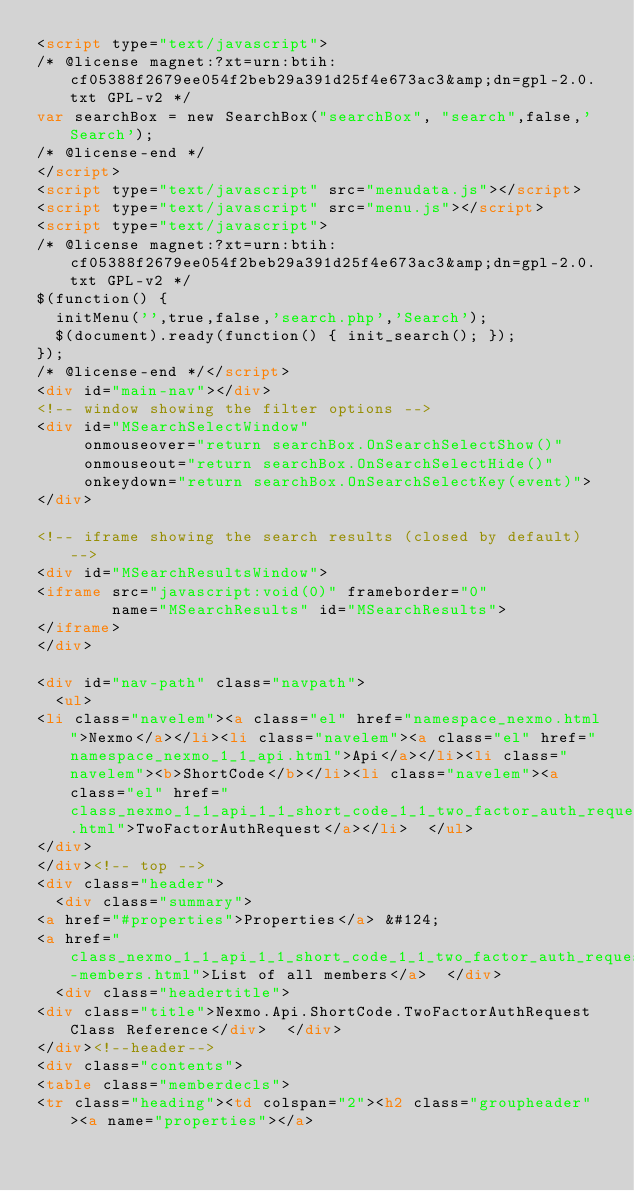Convert code to text. <code><loc_0><loc_0><loc_500><loc_500><_HTML_><script type="text/javascript">
/* @license magnet:?xt=urn:btih:cf05388f2679ee054f2beb29a391d25f4e673ac3&amp;dn=gpl-2.0.txt GPL-v2 */
var searchBox = new SearchBox("searchBox", "search",false,'Search');
/* @license-end */
</script>
<script type="text/javascript" src="menudata.js"></script>
<script type="text/javascript" src="menu.js"></script>
<script type="text/javascript">
/* @license magnet:?xt=urn:btih:cf05388f2679ee054f2beb29a391d25f4e673ac3&amp;dn=gpl-2.0.txt GPL-v2 */
$(function() {
  initMenu('',true,false,'search.php','Search');
  $(document).ready(function() { init_search(); });
});
/* @license-end */</script>
<div id="main-nav"></div>
<!-- window showing the filter options -->
<div id="MSearchSelectWindow"
     onmouseover="return searchBox.OnSearchSelectShow()"
     onmouseout="return searchBox.OnSearchSelectHide()"
     onkeydown="return searchBox.OnSearchSelectKey(event)">
</div>

<!-- iframe showing the search results (closed by default) -->
<div id="MSearchResultsWindow">
<iframe src="javascript:void(0)" frameborder="0" 
        name="MSearchResults" id="MSearchResults">
</iframe>
</div>

<div id="nav-path" class="navpath">
  <ul>
<li class="navelem"><a class="el" href="namespace_nexmo.html">Nexmo</a></li><li class="navelem"><a class="el" href="namespace_nexmo_1_1_api.html">Api</a></li><li class="navelem"><b>ShortCode</b></li><li class="navelem"><a class="el" href="class_nexmo_1_1_api_1_1_short_code_1_1_two_factor_auth_request.html">TwoFactorAuthRequest</a></li>  </ul>
</div>
</div><!-- top -->
<div class="header">
  <div class="summary">
<a href="#properties">Properties</a> &#124;
<a href="class_nexmo_1_1_api_1_1_short_code_1_1_two_factor_auth_request-members.html">List of all members</a>  </div>
  <div class="headertitle">
<div class="title">Nexmo.Api.ShortCode.TwoFactorAuthRequest Class Reference</div>  </div>
</div><!--header-->
<div class="contents">
<table class="memberdecls">
<tr class="heading"><td colspan="2"><h2 class="groupheader"><a name="properties"></a></code> 